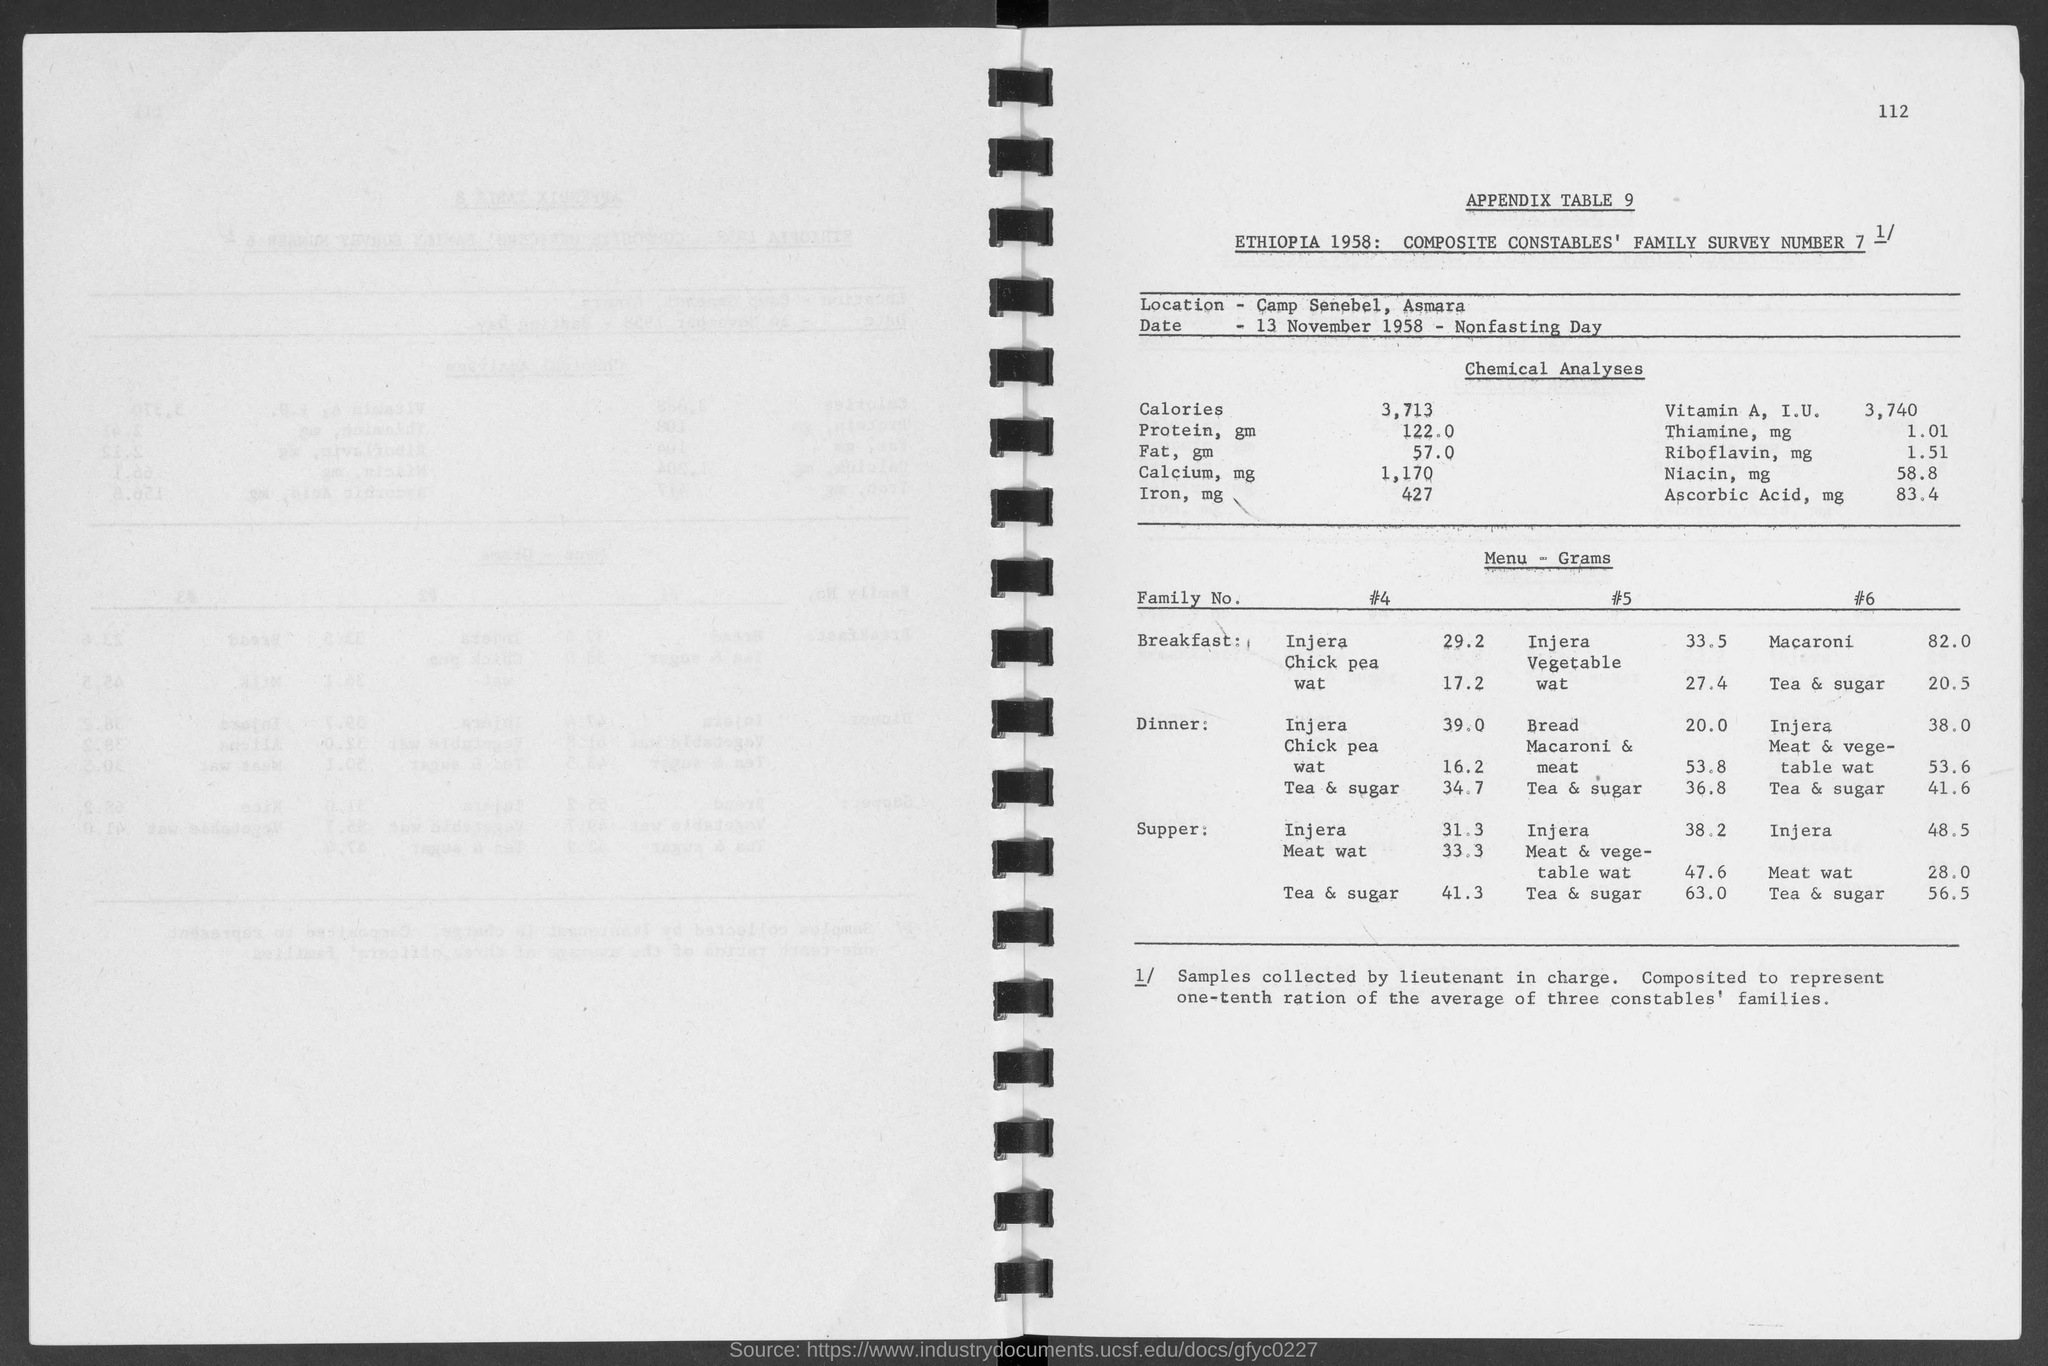Highlight a few significant elements in this photo. What is the page number?" the user asked, trailing off with "...112. The amount of protein is 122.0.. The location is called Camp Senebel, Asmara. The date mentioned in the document is 13 November 1958. There is 20.0kg of bread in the dinner of family number 5. 